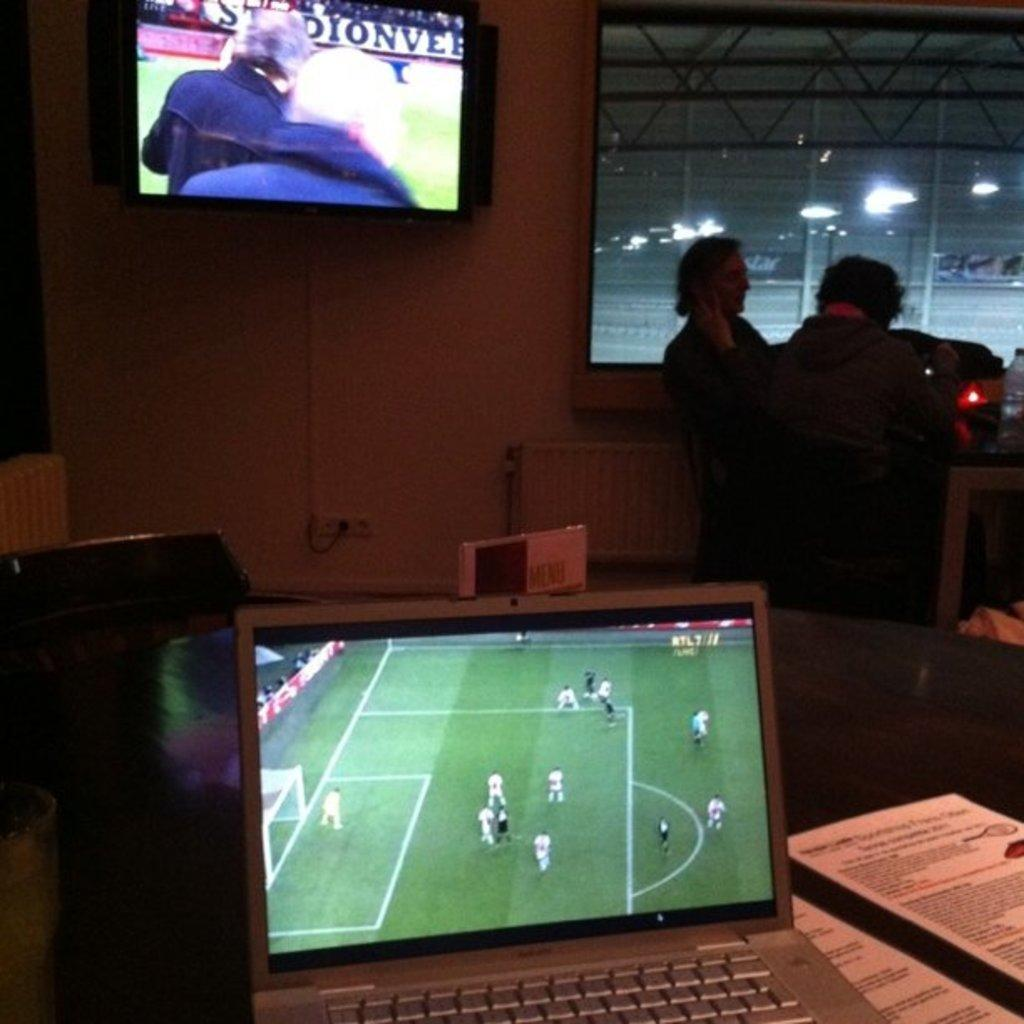What electronic device is present in the image? There is a laptop in the image. What can be seen in the background of the image? There are people standing in the background of the image, and there is a screen attached to the wall. What type of illumination is visible in the image? There are lights visible in the image. What type of glue is being used by the people in the image? There is no glue present in the image, and no indication that the people are using glue. What type of writing can be seen on the laptop screen? The image does not show the laptop screen, so it is impossible to determine if any writing is present. 